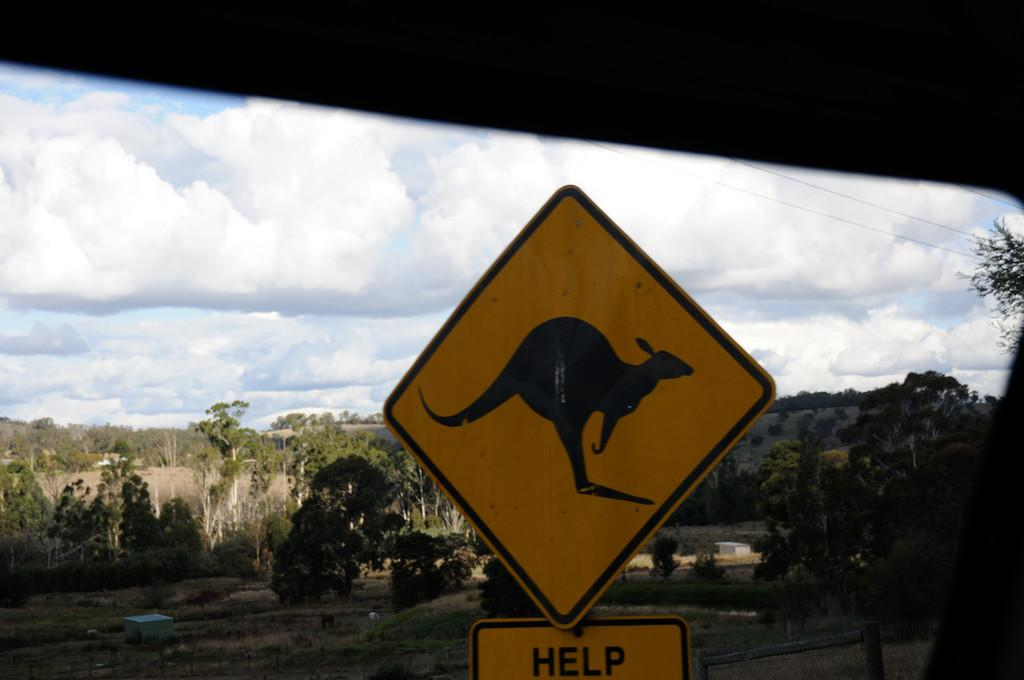Provide a one-sentence caption for the provided image. A diamond shaped road sign with a picture of a kangaroo reading Help underneath it. 